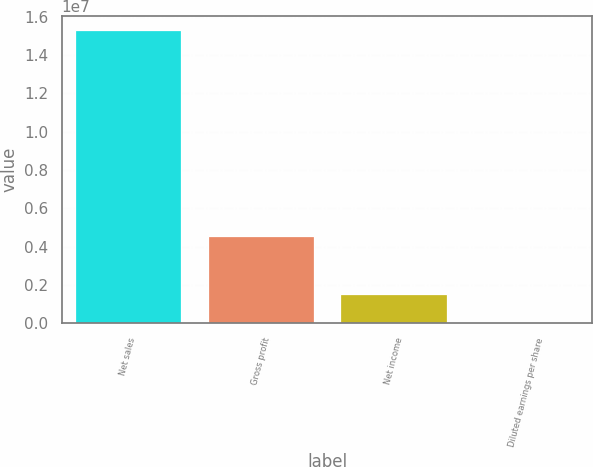Convert chart. <chart><loc_0><loc_0><loc_500><loc_500><bar_chart><fcel>Net sales<fcel>Gross profit<fcel>Net income<fcel>Diluted earnings per share<nl><fcel>1.528e+07<fcel>4.55585e+06<fcel>1.52801e+06<fcel>4.63<nl></chart> 